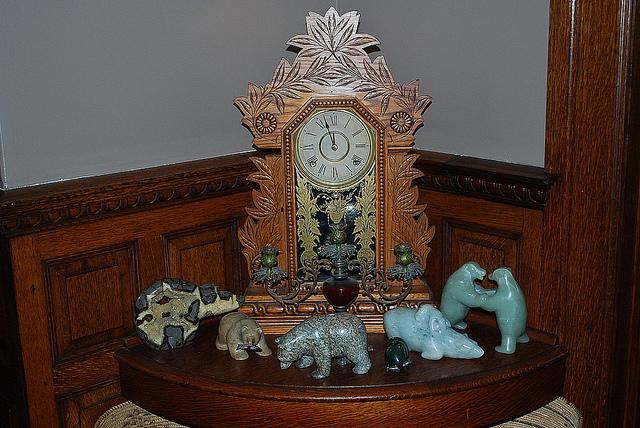What material are the two bears to the right of the desk clock made from? jade 